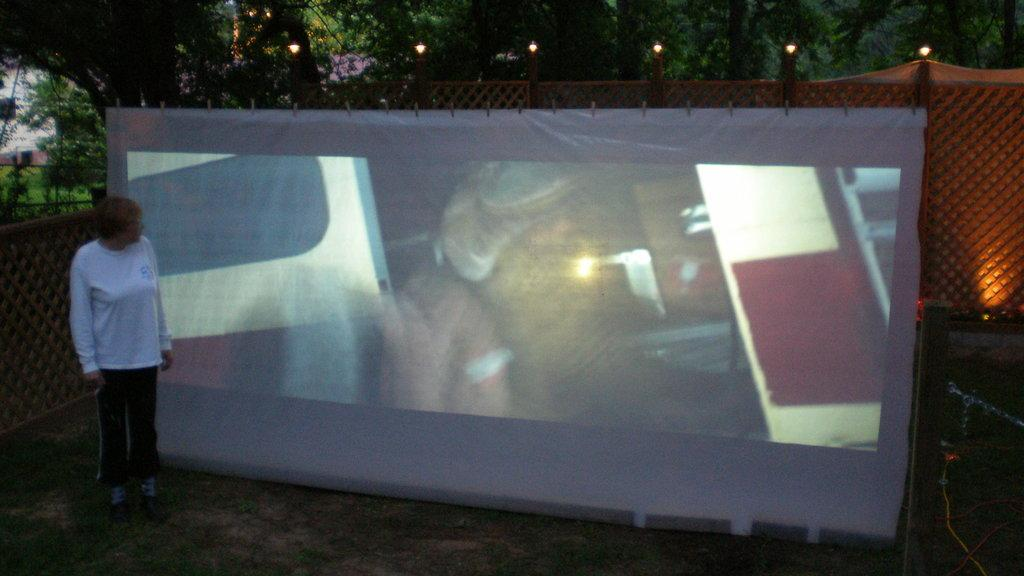What is the primary subject in the image? There is a woman standing in the image. What is the woman standing on? The woman is standing on the ground. What can be seen in the background of the image? There are trees in the background of the image. What type of objects are present in the image? There are some objects in the image. What is the woman wearing? There are clothes in the image, which the woman is likely wearing. What is the name of the woman's daughter in the image? There is no mention of a daughter in the image, so we cannot determine her name. 